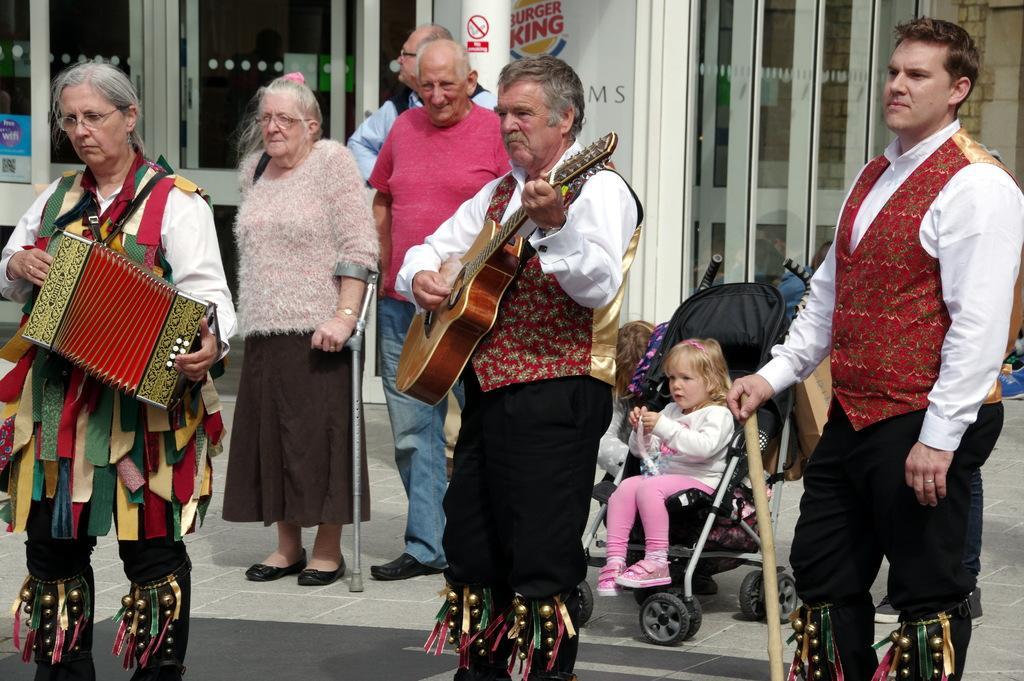Can you describe this image briefly? In the image we can see few persons were standing. In front we can see one man holding guitar. In the background there is a wall,pillar,sign board,glass and baby sitting on the wheel chair. 